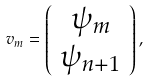<formula> <loc_0><loc_0><loc_500><loc_500>v _ { m } = \left ( \begin{array} { c } \psi _ { m } \\ \psi _ { n + 1 } \\ \end{array} \right ) ,</formula> 